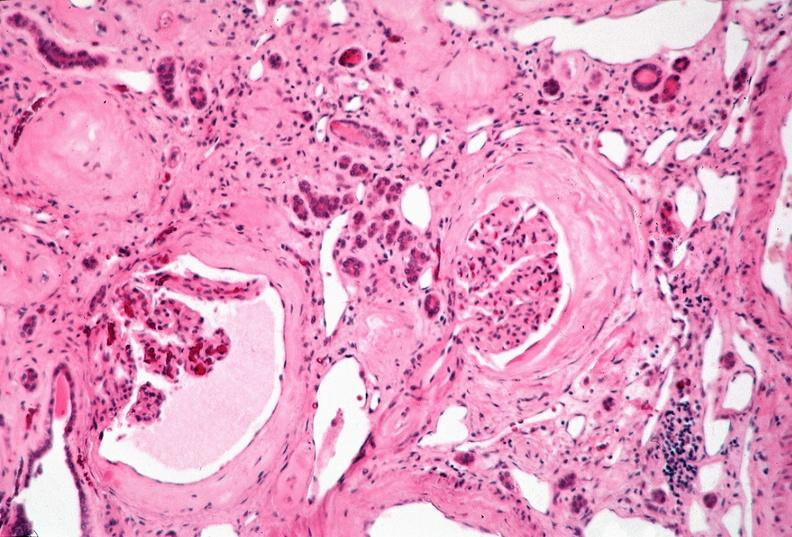does molluscum contagiosum show kidney, adult polycystic kidney?
Answer the question using a single word or phrase. No 